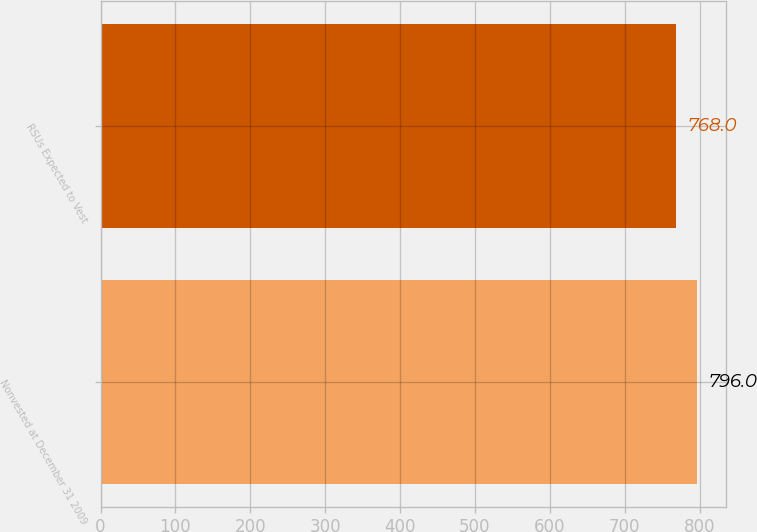Convert chart. <chart><loc_0><loc_0><loc_500><loc_500><bar_chart><fcel>Nonvested at December 31 2009<fcel>RSUs Expected to Vest<nl><fcel>796<fcel>768<nl></chart> 